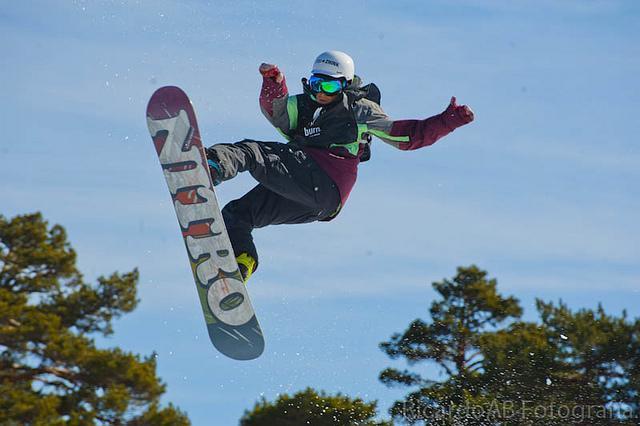How many dogs are there left to the lady?
Give a very brief answer. 0. 